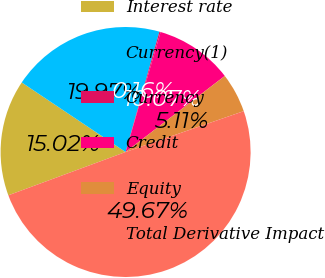<chart> <loc_0><loc_0><loc_500><loc_500><pie_chart><fcel>Interest rate<fcel>Currency(1)<fcel>Currency<fcel>Credit<fcel>Equity<fcel>Total Derivative Impact<nl><fcel>15.02%<fcel>19.97%<fcel>0.16%<fcel>10.07%<fcel>5.11%<fcel>49.67%<nl></chart> 